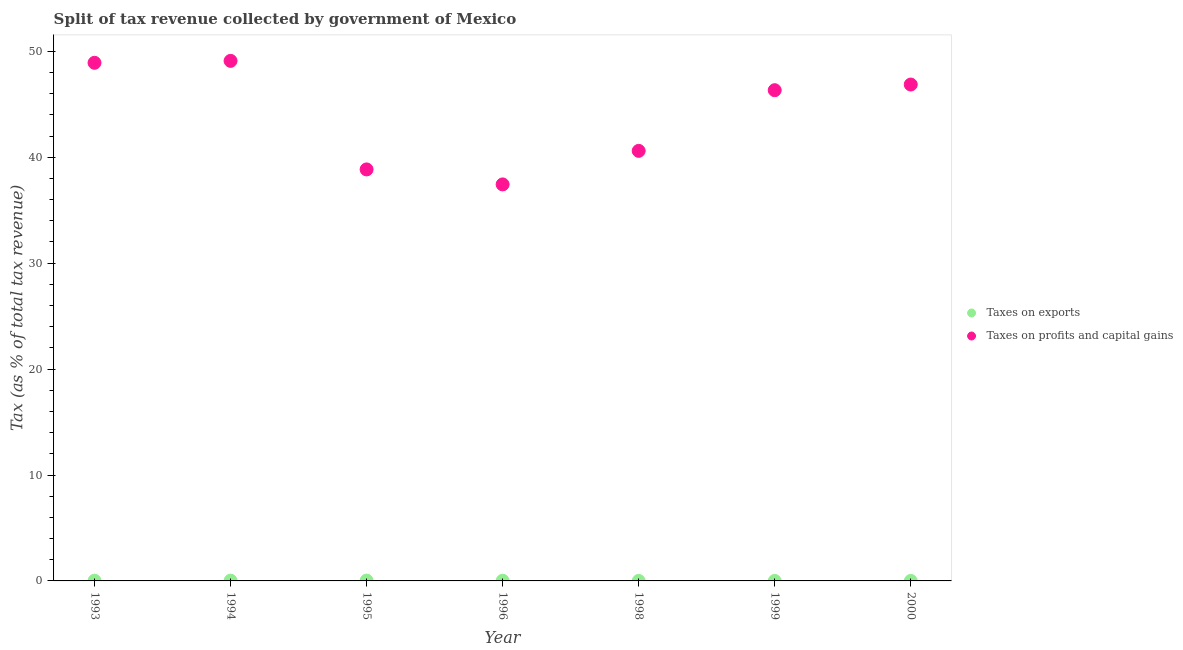What is the percentage of revenue obtained from taxes on exports in 1995?
Provide a short and direct response. 0.03. Across all years, what is the maximum percentage of revenue obtained from taxes on profits and capital gains?
Ensure brevity in your answer.  49.1. Across all years, what is the minimum percentage of revenue obtained from taxes on profits and capital gains?
Ensure brevity in your answer.  37.44. What is the total percentage of revenue obtained from taxes on exports in the graph?
Keep it short and to the point. 0.1. What is the difference between the percentage of revenue obtained from taxes on profits and capital gains in 1994 and that in 1995?
Your response must be concise. 10.25. What is the difference between the percentage of revenue obtained from taxes on exports in 1993 and the percentage of revenue obtained from taxes on profits and capital gains in 1996?
Ensure brevity in your answer.  -37.41. What is the average percentage of revenue obtained from taxes on profits and capital gains per year?
Ensure brevity in your answer.  44.01. In the year 1998, what is the difference between the percentage of revenue obtained from taxes on profits and capital gains and percentage of revenue obtained from taxes on exports?
Ensure brevity in your answer.  40.6. What is the ratio of the percentage of revenue obtained from taxes on exports in 1994 to that in 1998?
Your answer should be very brief. 103.73. Is the percentage of revenue obtained from taxes on exports in 1995 less than that in 1999?
Your answer should be very brief. No. What is the difference between the highest and the second highest percentage of revenue obtained from taxes on profits and capital gains?
Provide a short and direct response. 0.18. What is the difference between the highest and the lowest percentage of revenue obtained from taxes on profits and capital gains?
Your answer should be compact. 11.66. Is the sum of the percentage of revenue obtained from taxes on exports in 1994 and 1999 greater than the maximum percentage of revenue obtained from taxes on profits and capital gains across all years?
Ensure brevity in your answer.  No. Does the percentage of revenue obtained from taxes on profits and capital gains monotonically increase over the years?
Offer a terse response. No. How many dotlines are there?
Make the answer very short. 2. How many years are there in the graph?
Provide a short and direct response. 7. Are the values on the major ticks of Y-axis written in scientific E-notation?
Your response must be concise. No. Does the graph contain any zero values?
Your answer should be very brief. No. How many legend labels are there?
Give a very brief answer. 2. How are the legend labels stacked?
Ensure brevity in your answer.  Vertical. What is the title of the graph?
Make the answer very short. Split of tax revenue collected by government of Mexico. Does "Death rate" appear as one of the legend labels in the graph?
Make the answer very short. No. What is the label or title of the Y-axis?
Make the answer very short. Tax (as % of total tax revenue). What is the Tax (as % of total tax revenue) in Taxes on exports in 1993?
Your answer should be very brief. 0.02. What is the Tax (as % of total tax revenue) of Taxes on profits and capital gains in 1993?
Your answer should be compact. 48.92. What is the Tax (as % of total tax revenue) in Taxes on exports in 1994?
Your answer should be very brief. 0.03. What is the Tax (as % of total tax revenue) of Taxes on profits and capital gains in 1994?
Provide a succinct answer. 49.1. What is the Tax (as % of total tax revenue) of Taxes on exports in 1995?
Give a very brief answer. 0.03. What is the Tax (as % of total tax revenue) in Taxes on profits and capital gains in 1995?
Offer a terse response. 38.85. What is the Tax (as % of total tax revenue) of Taxes on exports in 1996?
Make the answer very short. 0.02. What is the Tax (as % of total tax revenue) in Taxes on profits and capital gains in 1996?
Provide a short and direct response. 37.44. What is the Tax (as % of total tax revenue) in Taxes on exports in 1998?
Ensure brevity in your answer.  0. What is the Tax (as % of total tax revenue) in Taxes on profits and capital gains in 1998?
Provide a short and direct response. 40.6. What is the Tax (as % of total tax revenue) of Taxes on exports in 1999?
Your response must be concise. 0. What is the Tax (as % of total tax revenue) of Taxes on profits and capital gains in 1999?
Offer a very short reply. 46.33. What is the Tax (as % of total tax revenue) of Taxes on exports in 2000?
Ensure brevity in your answer.  0. What is the Tax (as % of total tax revenue) in Taxes on profits and capital gains in 2000?
Provide a short and direct response. 46.86. Across all years, what is the maximum Tax (as % of total tax revenue) of Taxes on exports?
Offer a terse response. 0.03. Across all years, what is the maximum Tax (as % of total tax revenue) in Taxes on profits and capital gains?
Offer a very short reply. 49.1. Across all years, what is the minimum Tax (as % of total tax revenue) in Taxes on exports?
Provide a succinct answer. 0. Across all years, what is the minimum Tax (as % of total tax revenue) of Taxes on profits and capital gains?
Provide a short and direct response. 37.44. What is the total Tax (as % of total tax revenue) of Taxes on exports in the graph?
Provide a short and direct response. 0.1. What is the total Tax (as % of total tax revenue) in Taxes on profits and capital gains in the graph?
Make the answer very short. 308.1. What is the difference between the Tax (as % of total tax revenue) of Taxes on exports in 1993 and that in 1994?
Your answer should be compact. -0. What is the difference between the Tax (as % of total tax revenue) in Taxes on profits and capital gains in 1993 and that in 1994?
Offer a terse response. -0.18. What is the difference between the Tax (as % of total tax revenue) of Taxes on exports in 1993 and that in 1995?
Provide a short and direct response. -0.01. What is the difference between the Tax (as % of total tax revenue) of Taxes on profits and capital gains in 1993 and that in 1995?
Provide a short and direct response. 10.07. What is the difference between the Tax (as % of total tax revenue) of Taxes on exports in 1993 and that in 1996?
Your response must be concise. 0. What is the difference between the Tax (as % of total tax revenue) in Taxes on profits and capital gains in 1993 and that in 1996?
Make the answer very short. 11.48. What is the difference between the Tax (as % of total tax revenue) in Taxes on exports in 1993 and that in 1998?
Ensure brevity in your answer.  0.02. What is the difference between the Tax (as % of total tax revenue) of Taxes on profits and capital gains in 1993 and that in 1998?
Keep it short and to the point. 8.31. What is the difference between the Tax (as % of total tax revenue) of Taxes on exports in 1993 and that in 1999?
Make the answer very short. 0.02. What is the difference between the Tax (as % of total tax revenue) in Taxes on profits and capital gains in 1993 and that in 1999?
Offer a very short reply. 2.59. What is the difference between the Tax (as % of total tax revenue) of Taxes on exports in 1993 and that in 2000?
Keep it short and to the point. 0.02. What is the difference between the Tax (as % of total tax revenue) in Taxes on profits and capital gains in 1993 and that in 2000?
Your answer should be compact. 2.05. What is the difference between the Tax (as % of total tax revenue) in Taxes on exports in 1994 and that in 1995?
Make the answer very short. -0.01. What is the difference between the Tax (as % of total tax revenue) in Taxes on profits and capital gains in 1994 and that in 1995?
Your answer should be very brief. 10.25. What is the difference between the Tax (as % of total tax revenue) in Taxes on exports in 1994 and that in 1996?
Offer a very short reply. 0.01. What is the difference between the Tax (as % of total tax revenue) of Taxes on profits and capital gains in 1994 and that in 1996?
Your response must be concise. 11.66. What is the difference between the Tax (as % of total tax revenue) in Taxes on exports in 1994 and that in 1998?
Your answer should be very brief. 0.03. What is the difference between the Tax (as % of total tax revenue) of Taxes on profits and capital gains in 1994 and that in 1998?
Provide a short and direct response. 8.5. What is the difference between the Tax (as % of total tax revenue) of Taxes on exports in 1994 and that in 1999?
Provide a succinct answer. 0.03. What is the difference between the Tax (as % of total tax revenue) in Taxes on profits and capital gains in 1994 and that in 1999?
Keep it short and to the point. 2.77. What is the difference between the Tax (as % of total tax revenue) of Taxes on exports in 1994 and that in 2000?
Provide a succinct answer. 0.03. What is the difference between the Tax (as % of total tax revenue) of Taxes on profits and capital gains in 1994 and that in 2000?
Provide a short and direct response. 2.23. What is the difference between the Tax (as % of total tax revenue) of Taxes on exports in 1995 and that in 1996?
Provide a succinct answer. 0.01. What is the difference between the Tax (as % of total tax revenue) of Taxes on profits and capital gains in 1995 and that in 1996?
Your answer should be compact. 1.42. What is the difference between the Tax (as % of total tax revenue) in Taxes on exports in 1995 and that in 1998?
Keep it short and to the point. 0.03. What is the difference between the Tax (as % of total tax revenue) in Taxes on profits and capital gains in 1995 and that in 1998?
Your answer should be very brief. -1.75. What is the difference between the Tax (as % of total tax revenue) in Taxes on exports in 1995 and that in 1999?
Your answer should be compact. 0.03. What is the difference between the Tax (as % of total tax revenue) of Taxes on profits and capital gains in 1995 and that in 1999?
Your response must be concise. -7.48. What is the difference between the Tax (as % of total tax revenue) of Taxes on exports in 1995 and that in 2000?
Your response must be concise. 0.03. What is the difference between the Tax (as % of total tax revenue) of Taxes on profits and capital gains in 1995 and that in 2000?
Give a very brief answer. -8.01. What is the difference between the Tax (as % of total tax revenue) of Taxes on exports in 1996 and that in 1998?
Make the answer very short. 0.02. What is the difference between the Tax (as % of total tax revenue) of Taxes on profits and capital gains in 1996 and that in 1998?
Keep it short and to the point. -3.17. What is the difference between the Tax (as % of total tax revenue) of Taxes on exports in 1996 and that in 1999?
Make the answer very short. 0.02. What is the difference between the Tax (as % of total tax revenue) in Taxes on profits and capital gains in 1996 and that in 1999?
Make the answer very short. -8.89. What is the difference between the Tax (as % of total tax revenue) of Taxes on exports in 1996 and that in 2000?
Provide a short and direct response. 0.02. What is the difference between the Tax (as % of total tax revenue) of Taxes on profits and capital gains in 1996 and that in 2000?
Provide a short and direct response. -9.43. What is the difference between the Tax (as % of total tax revenue) of Taxes on profits and capital gains in 1998 and that in 1999?
Provide a short and direct response. -5.73. What is the difference between the Tax (as % of total tax revenue) of Taxes on exports in 1998 and that in 2000?
Provide a succinct answer. -0. What is the difference between the Tax (as % of total tax revenue) in Taxes on profits and capital gains in 1998 and that in 2000?
Provide a succinct answer. -6.26. What is the difference between the Tax (as % of total tax revenue) in Taxes on exports in 1999 and that in 2000?
Provide a succinct answer. -0. What is the difference between the Tax (as % of total tax revenue) in Taxes on profits and capital gains in 1999 and that in 2000?
Offer a very short reply. -0.53. What is the difference between the Tax (as % of total tax revenue) in Taxes on exports in 1993 and the Tax (as % of total tax revenue) in Taxes on profits and capital gains in 1994?
Your answer should be compact. -49.08. What is the difference between the Tax (as % of total tax revenue) in Taxes on exports in 1993 and the Tax (as % of total tax revenue) in Taxes on profits and capital gains in 1995?
Give a very brief answer. -38.83. What is the difference between the Tax (as % of total tax revenue) in Taxes on exports in 1993 and the Tax (as % of total tax revenue) in Taxes on profits and capital gains in 1996?
Ensure brevity in your answer.  -37.41. What is the difference between the Tax (as % of total tax revenue) of Taxes on exports in 1993 and the Tax (as % of total tax revenue) of Taxes on profits and capital gains in 1998?
Offer a terse response. -40.58. What is the difference between the Tax (as % of total tax revenue) of Taxes on exports in 1993 and the Tax (as % of total tax revenue) of Taxes on profits and capital gains in 1999?
Your answer should be very brief. -46.31. What is the difference between the Tax (as % of total tax revenue) in Taxes on exports in 1993 and the Tax (as % of total tax revenue) in Taxes on profits and capital gains in 2000?
Offer a very short reply. -46.84. What is the difference between the Tax (as % of total tax revenue) of Taxes on exports in 1994 and the Tax (as % of total tax revenue) of Taxes on profits and capital gains in 1995?
Your answer should be very brief. -38.82. What is the difference between the Tax (as % of total tax revenue) of Taxes on exports in 1994 and the Tax (as % of total tax revenue) of Taxes on profits and capital gains in 1996?
Keep it short and to the point. -37.41. What is the difference between the Tax (as % of total tax revenue) of Taxes on exports in 1994 and the Tax (as % of total tax revenue) of Taxes on profits and capital gains in 1998?
Ensure brevity in your answer.  -40.58. What is the difference between the Tax (as % of total tax revenue) in Taxes on exports in 1994 and the Tax (as % of total tax revenue) in Taxes on profits and capital gains in 1999?
Ensure brevity in your answer.  -46.3. What is the difference between the Tax (as % of total tax revenue) of Taxes on exports in 1994 and the Tax (as % of total tax revenue) of Taxes on profits and capital gains in 2000?
Offer a terse response. -46.84. What is the difference between the Tax (as % of total tax revenue) in Taxes on exports in 1995 and the Tax (as % of total tax revenue) in Taxes on profits and capital gains in 1996?
Make the answer very short. -37.4. What is the difference between the Tax (as % of total tax revenue) in Taxes on exports in 1995 and the Tax (as % of total tax revenue) in Taxes on profits and capital gains in 1998?
Ensure brevity in your answer.  -40.57. What is the difference between the Tax (as % of total tax revenue) in Taxes on exports in 1995 and the Tax (as % of total tax revenue) in Taxes on profits and capital gains in 1999?
Keep it short and to the point. -46.3. What is the difference between the Tax (as % of total tax revenue) in Taxes on exports in 1995 and the Tax (as % of total tax revenue) in Taxes on profits and capital gains in 2000?
Give a very brief answer. -46.83. What is the difference between the Tax (as % of total tax revenue) in Taxes on exports in 1996 and the Tax (as % of total tax revenue) in Taxes on profits and capital gains in 1998?
Provide a succinct answer. -40.58. What is the difference between the Tax (as % of total tax revenue) in Taxes on exports in 1996 and the Tax (as % of total tax revenue) in Taxes on profits and capital gains in 1999?
Provide a succinct answer. -46.31. What is the difference between the Tax (as % of total tax revenue) of Taxes on exports in 1996 and the Tax (as % of total tax revenue) of Taxes on profits and capital gains in 2000?
Offer a very short reply. -46.85. What is the difference between the Tax (as % of total tax revenue) of Taxes on exports in 1998 and the Tax (as % of total tax revenue) of Taxes on profits and capital gains in 1999?
Ensure brevity in your answer.  -46.33. What is the difference between the Tax (as % of total tax revenue) of Taxes on exports in 1998 and the Tax (as % of total tax revenue) of Taxes on profits and capital gains in 2000?
Ensure brevity in your answer.  -46.86. What is the difference between the Tax (as % of total tax revenue) of Taxes on exports in 1999 and the Tax (as % of total tax revenue) of Taxes on profits and capital gains in 2000?
Your answer should be very brief. -46.86. What is the average Tax (as % of total tax revenue) of Taxes on exports per year?
Provide a short and direct response. 0.01. What is the average Tax (as % of total tax revenue) of Taxes on profits and capital gains per year?
Your answer should be compact. 44.01. In the year 1993, what is the difference between the Tax (as % of total tax revenue) in Taxes on exports and Tax (as % of total tax revenue) in Taxes on profits and capital gains?
Provide a short and direct response. -48.89. In the year 1994, what is the difference between the Tax (as % of total tax revenue) in Taxes on exports and Tax (as % of total tax revenue) in Taxes on profits and capital gains?
Offer a terse response. -49.07. In the year 1995, what is the difference between the Tax (as % of total tax revenue) of Taxes on exports and Tax (as % of total tax revenue) of Taxes on profits and capital gains?
Ensure brevity in your answer.  -38.82. In the year 1996, what is the difference between the Tax (as % of total tax revenue) in Taxes on exports and Tax (as % of total tax revenue) in Taxes on profits and capital gains?
Your answer should be very brief. -37.42. In the year 1998, what is the difference between the Tax (as % of total tax revenue) in Taxes on exports and Tax (as % of total tax revenue) in Taxes on profits and capital gains?
Make the answer very short. -40.6. In the year 1999, what is the difference between the Tax (as % of total tax revenue) in Taxes on exports and Tax (as % of total tax revenue) in Taxes on profits and capital gains?
Offer a terse response. -46.33. In the year 2000, what is the difference between the Tax (as % of total tax revenue) of Taxes on exports and Tax (as % of total tax revenue) of Taxes on profits and capital gains?
Your answer should be very brief. -46.86. What is the ratio of the Tax (as % of total tax revenue) of Taxes on exports in 1993 to that in 1994?
Your answer should be compact. 0.83. What is the ratio of the Tax (as % of total tax revenue) in Taxes on profits and capital gains in 1993 to that in 1994?
Offer a terse response. 1. What is the ratio of the Tax (as % of total tax revenue) in Taxes on exports in 1993 to that in 1995?
Give a very brief answer. 0.68. What is the ratio of the Tax (as % of total tax revenue) of Taxes on profits and capital gains in 1993 to that in 1995?
Give a very brief answer. 1.26. What is the ratio of the Tax (as % of total tax revenue) in Taxes on exports in 1993 to that in 1996?
Keep it short and to the point. 1.2. What is the ratio of the Tax (as % of total tax revenue) of Taxes on profits and capital gains in 1993 to that in 1996?
Offer a terse response. 1.31. What is the ratio of the Tax (as % of total tax revenue) of Taxes on exports in 1993 to that in 1998?
Ensure brevity in your answer.  85.94. What is the ratio of the Tax (as % of total tax revenue) of Taxes on profits and capital gains in 1993 to that in 1998?
Ensure brevity in your answer.  1.2. What is the ratio of the Tax (as % of total tax revenue) of Taxes on exports in 1993 to that in 1999?
Provide a short and direct response. 108.21. What is the ratio of the Tax (as % of total tax revenue) in Taxes on profits and capital gains in 1993 to that in 1999?
Offer a terse response. 1.06. What is the ratio of the Tax (as % of total tax revenue) of Taxes on exports in 1993 to that in 2000?
Your answer should be very brief. 35.09. What is the ratio of the Tax (as % of total tax revenue) of Taxes on profits and capital gains in 1993 to that in 2000?
Ensure brevity in your answer.  1.04. What is the ratio of the Tax (as % of total tax revenue) in Taxes on exports in 1994 to that in 1995?
Provide a short and direct response. 0.82. What is the ratio of the Tax (as % of total tax revenue) of Taxes on profits and capital gains in 1994 to that in 1995?
Keep it short and to the point. 1.26. What is the ratio of the Tax (as % of total tax revenue) in Taxes on exports in 1994 to that in 1996?
Provide a succinct answer. 1.44. What is the ratio of the Tax (as % of total tax revenue) in Taxes on profits and capital gains in 1994 to that in 1996?
Keep it short and to the point. 1.31. What is the ratio of the Tax (as % of total tax revenue) in Taxes on exports in 1994 to that in 1998?
Make the answer very short. 103.73. What is the ratio of the Tax (as % of total tax revenue) in Taxes on profits and capital gains in 1994 to that in 1998?
Make the answer very short. 1.21. What is the ratio of the Tax (as % of total tax revenue) in Taxes on exports in 1994 to that in 1999?
Your response must be concise. 130.61. What is the ratio of the Tax (as % of total tax revenue) of Taxes on profits and capital gains in 1994 to that in 1999?
Keep it short and to the point. 1.06. What is the ratio of the Tax (as % of total tax revenue) of Taxes on exports in 1994 to that in 2000?
Offer a terse response. 42.36. What is the ratio of the Tax (as % of total tax revenue) of Taxes on profits and capital gains in 1994 to that in 2000?
Your answer should be compact. 1.05. What is the ratio of the Tax (as % of total tax revenue) of Taxes on exports in 1995 to that in 1996?
Keep it short and to the point. 1.76. What is the ratio of the Tax (as % of total tax revenue) in Taxes on profits and capital gains in 1995 to that in 1996?
Offer a very short reply. 1.04. What is the ratio of the Tax (as % of total tax revenue) of Taxes on exports in 1995 to that in 1998?
Give a very brief answer. 126.09. What is the ratio of the Tax (as % of total tax revenue) in Taxes on profits and capital gains in 1995 to that in 1998?
Make the answer very short. 0.96. What is the ratio of the Tax (as % of total tax revenue) in Taxes on exports in 1995 to that in 1999?
Make the answer very short. 158.78. What is the ratio of the Tax (as % of total tax revenue) of Taxes on profits and capital gains in 1995 to that in 1999?
Ensure brevity in your answer.  0.84. What is the ratio of the Tax (as % of total tax revenue) in Taxes on exports in 1995 to that in 2000?
Offer a terse response. 51.49. What is the ratio of the Tax (as % of total tax revenue) in Taxes on profits and capital gains in 1995 to that in 2000?
Give a very brief answer. 0.83. What is the ratio of the Tax (as % of total tax revenue) of Taxes on exports in 1996 to that in 1998?
Make the answer very short. 71.83. What is the ratio of the Tax (as % of total tax revenue) of Taxes on profits and capital gains in 1996 to that in 1998?
Your answer should be compact. 0.92. What is the ratio of the Tax (as % of total tax revenue) in Taxes on exports in 1996 to that in 1999?
Provide a succinct answer. 90.45. What is the ratio of the Tax (as % of total tax revenue) in Taxes on profits and capital gains in 1996 to that in 1999?
Provide a succinct answer. 0.81. What is the ratio of the Tax (as % of total tax revenue) of Taxes on exports in 1996 to that in 2000?
Make the answer very short. 29.33. What is the ratio of the Tax (as % of total tax revenue) in Taxes on profits and capital gains in 1996 to that in 2000?
Offer a very short reply. 0.8. What is the ratio of the Tax (as % of total tax revenue) in Taxes on exports in 1998 to that in 1999?
Give a very brief answer. 1.26. What is the ratio of the Tax (as % of total tax revenue) in Taxes on profits and capital gains in 1998 to that in 1999?
Provide a short and direct response. 0.88. What is the ratio of the Tax (as % of total tax revenue) in Taxes on exports in 1998 to that in 2000?
Provide a short and direct response. 0.41. What is the ratio of the Tax (as % of total tax revenue) in Taxes on profits and capital gains in 1998 to that in 2000?
Offer a terse response. 0.87. What is the ratio of the Tax (as % of total tax revenue) in Taxes on exports in 1999 to that in 2000?
Ensure brevity in your answer.  0.32. What is the difference between the highest and the second highest Tax (as % of total tax revenue) in Taxes on exports?
Provide a succinct answer. 0.01. What is the difference between the highest and the second highest Tax (as % of total tax revenue) in Taxes on profits and capital gains?
Offer a very short reply. 0.18. What is the difference between the highest and the lowest Tax (as % of total tax revenue) in Taxes on exports?
Your answer should be very brief. 0.03. What is the difference between the highest and the lowest Tax (as % of total tax revenue) of Taxes on profits and capital gains?
Keep it short and to the point. 11.66. 